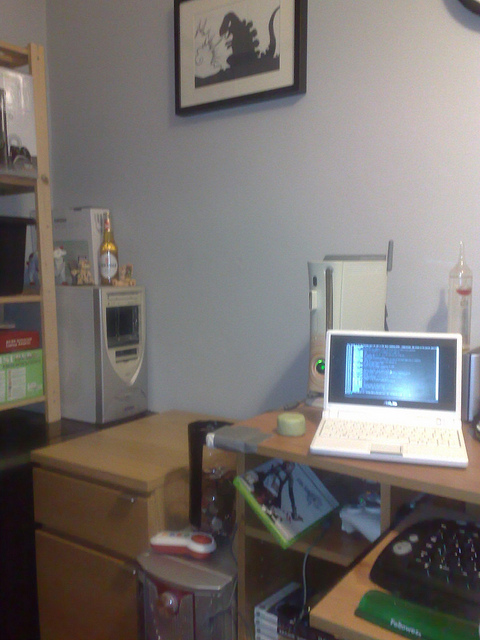<image>What type of DVD is setting on the desk? I don't know what type of DVD is setting on the desk. It can be a documentary, video game, or movie. What type of DVD is setting on the desk? I am not sure what type of DVD is setting on the desk. It can be a documentary, video game, sony, game, round or movie. 